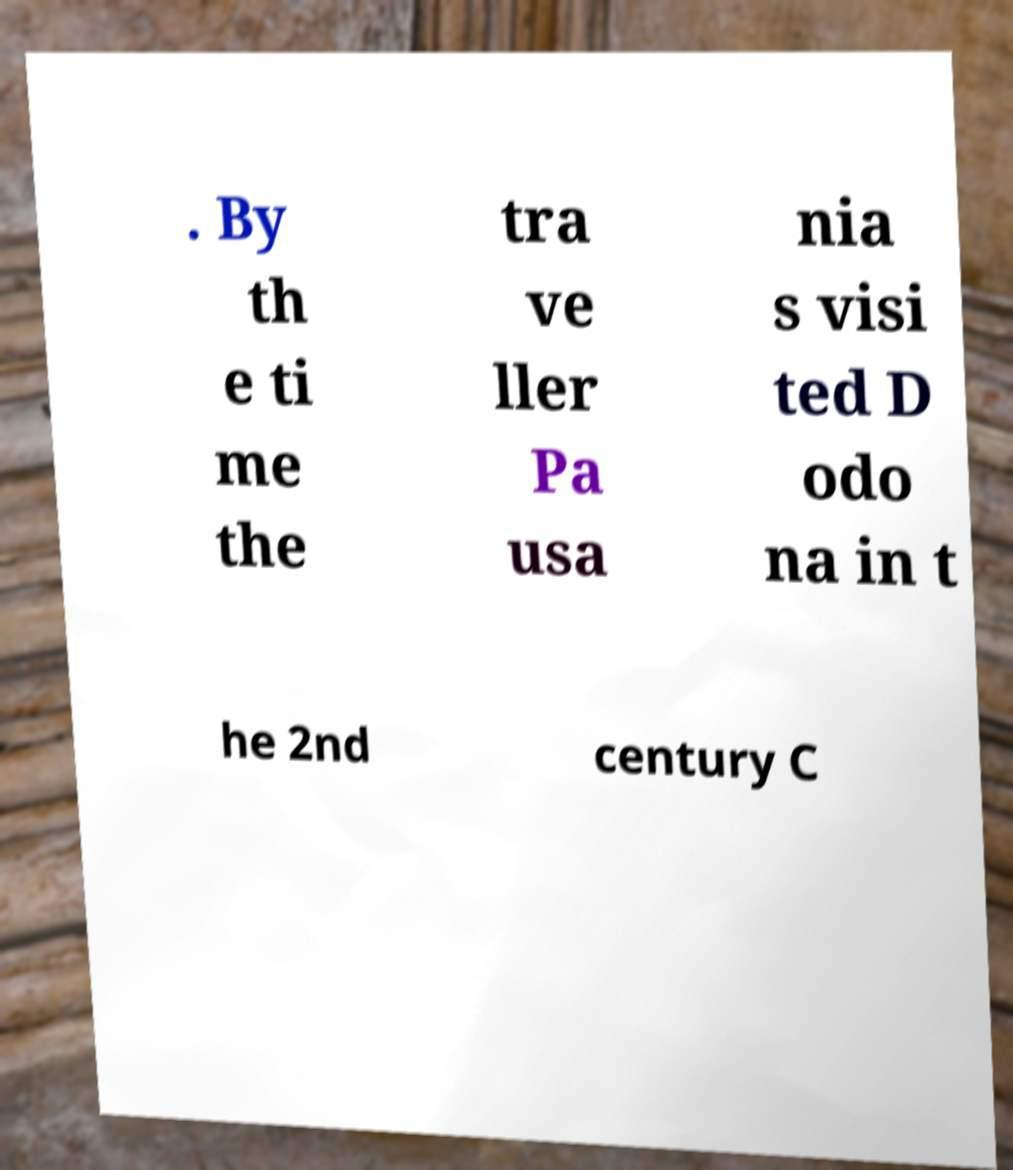Can you accurately transcribe the text from the provided image for me? . By th e ti me the tra ve ller Pa usa nia s visi ted D odo na in t he 2nd century C 